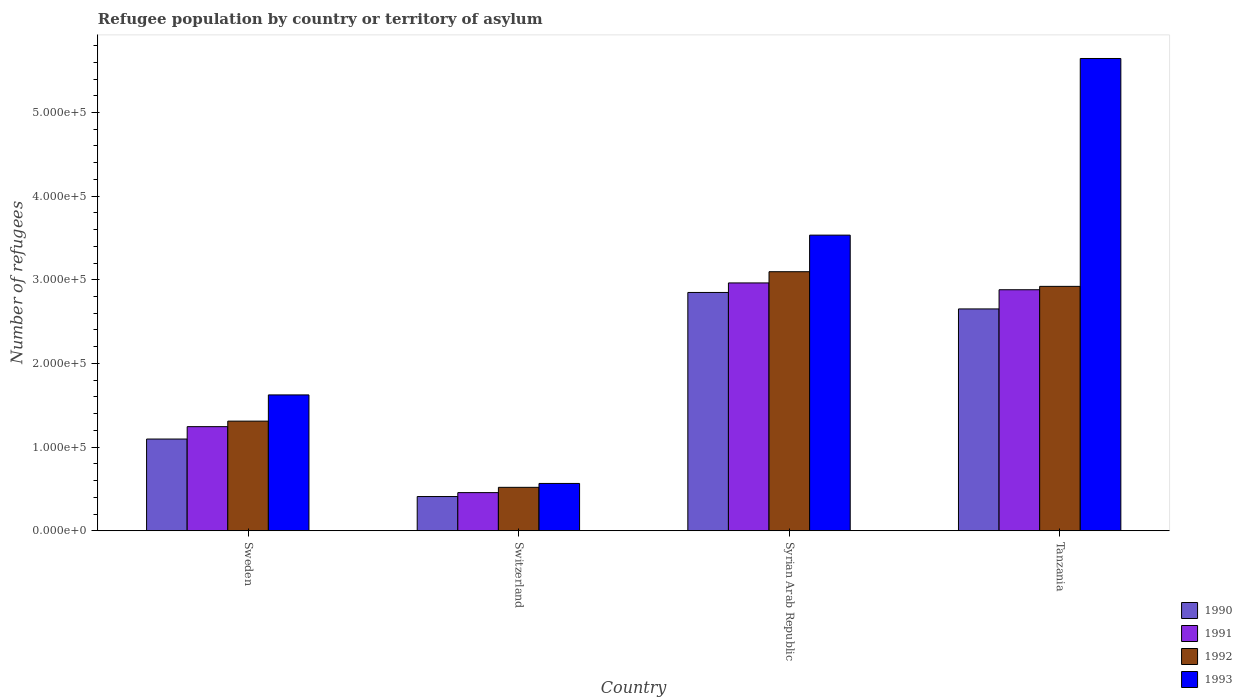Are the number of bars per tick equal to the number of legend labels?
Offer a terse response. Yes. Are the number of bars on each tick of the X-axis equal?
Your answer should be very brief. Yes. How many bars are there on the 2nd tick from the left?
Your answer should be compact. 4. What is the label of the 4th group of bars from the left?
Keep it short and to the point. Tanzania. In how many cases, is the number of bars for a given country not equal to the number of legend labels?
Your answer should be very brief. 0. What is the number of refugees in 1993 in Syrian Arab Republic?
Keep it short and to the point. 3.53e+05. Across all countries, what is the maximum number of refugees in 1991?
Give a very brief answer. 2.96e+05. Across all countries, what is the minimum number of refugees in 1991?
Your response must be concise. 4.56e+04. In which country was the number of refugees in 1993 maximum?
Your response must be concise. Tanzania. In which country was the number of refugees in 1991 minimum?
Give a very brief answer. Switzerland. What is the total number of refugees in 1991 in the graph?
Your answer should be very brief. 7.54e+05. What is the difference between the number of refugees in 1992 in Sweden and that in Switzerland?
Your answer should be very brief. 7.91e+04. What is the difference between the number of refugees in 1993 in Sweden and the number of refugees in 1991 in Syrian Arab Republic?
Your response must be concise. -1.34e+05. What is the average number of refugees in 1991 per country?
Provide a short and direct response. 1.89e+05. What is the difference between the number of refugees of/in 1991 and number of refugees of/in 1993 in Syrian Arab Republic?
Offer a very short reply. -5.71e+04. In how many countries, is the number of refugees in 1991 greater than 400000?
Provide a succinct answer. 0. What is the ratio of the number of refugees in 1992 in Sweden to that in Syrian Arab Republic?
Your response must be concise. 0.42. Is the number of refugees in 1990 in Sweden less than that in Syrian Arab Republic?
Offer a terse response. Yes. Is the difference between the number of refugees in 1991 in Syrian Arab Republic and Tanzania greater than the difference between the number of refugees in 1993 in Syrian Arab Republic and Tanzania?
Offer a very short reply. Yes. What is the difference between the highest and the second highest number of refugees in 1991?
Ensure brevity in your answer.  1.72e+05. What is the difference between the highest and the lowest number of refugees in 1993?
Give a very brief answer. 5.08e+05. Is the sum of the number of refugees in 1992 in Sweden and Switzerland greater than the maximum number of refugees in 1993 across all countries?
Provide a short and direct response. No. What does the 2nd bar from the left in Syrian Arab Republic represents?
Make the answer very short. 1991. What does the 3rd bar from the right in Sweden represents?
Keep it short and to the point. 1991. Is it the case that in every country, the sum of the number of refugees in 1992 and number of refugees in 1993 is greater than the number of refugees in 1990?
Keep it short and to the point. Yes. How many countries are there in the graph?
Provide a short and direct response. 4. Are the values on the major ticks of Y-axis written in scientific E-notation?
Offer a terse response. Yes. Does the graph contain grids?
Keep it short and to the point. No. What is the title of the graph?
Make the answer very short. Refugee population by country or territory of asylum. What is the label or title of the Y-axis?
Give a very brief answer. Number of refugees. What is the Number of refugees of 1990 in Sweden?
Your response must be concise. 1.10e+05. What is the Number of refugees in 1991 in Sweden?
Ensure brevity in your answer.  1.24e+05. What is the Number of refugees in 1992 in Sweden?
Offer a very short reply. 1.31e+05. What is the Number of refugees in 1993 in Sweden?
Ensure brevity in your answer.  1.62e+05. What is the Number of refugees in 1990 in Switzerland?
Make the answer very short. 4.09e+04. What is the Number of refugees in 1991 in Switzerland?
Your answer should be very brief. 4.56e+04. What is the Number of refugees of 1992 in Switzerland?
Offer a very short reply. 5.19e+04. What is the Number of refugees in 1993 in Switzerland?
Your answer should be very brief. 5.66e+04. What is the Number of refugees of 1990 in Syrian Arab Republic?
Offer a terse response. 2.85e+05. What is the Number of refugees of 1991 in Syrian Arab Republic?
Offer a terse response. 2.96e+05. What is the Number of refugees in 1992 in Syrian Arab Republic?
Your answer should be compact. 3.10e+05. What is the Number of refugees in 1993 in Syrian Arab Republic?
Offer a very short reply. 3.53e+05. What is the Number of refugees of 1990 in Tanzania?
Your response must be concise. 2.65e+05. What is the Number of refugees in 1991 in Tanzania?
Your answer should be compact. 2.88e+05. What is the Number of refugees in 1992 in Tanzania?
Your answer should be very brief. 2.92e+05. What is the Number of refugees of 1993 in Tanzania?
Your response must be concise. 5.65e+05. Across all countries, what is the maximum Number of refugees of 1990?
Provide a succinct answer. 2.85e+05. Across all countries, what is the maximum Number of refugees in 1991?
Provide a short and direct response. 2.96e+05. Across all countries, what is the maximum Number of refugees of 1992?
Provide a succinct answer. 3.10e+05. Across all countries, what is the maximum Number of refugees in 1993?
Your response must be concise. 5.65e+05. Across all countries, what is the minimum Number of refugees in 1990?
Offer a terse response. 4.09e+04. Across all countries, what is the minimum Number of refugees in 1991?
Make the answer very short. 4.56e+04. Across all countries, what is the minimum Number of refugees of 1992?
Provide a succinct answer. 5.19e+04. Across all countries, what is the minimum Number of refugees in 1993?
Offer a terse response. 5.66e+04. What is the total Number of refugees in 1990 in the graph?
Your answer should be compact. 7.01e+05. What is the total Number of refugees of 1991 in the graph?
Ensure brevity in your answer.  7.54e+05. What is the total Number of refugees of 1992 in the graph?
Your response must be concise. 7.85e+05. What is the total Number of refugees of 1993 in the graph?
Make the answer very short. 1.14e+06. What is the difference between the Number of refugees in 1990 in Sweden and that in Switzerland?
Provide a short and direct response. 6.87e+04. What is the difference between the Number of refugees in 1991 in Sweden and that in Switzerland?
Provide a succinct answer. 7.88e+04. What is the difference between the Number of refugees in 1992 in Sweden and that in Switzerland?
Give a very brief answer. 7.91e+04. What is the difference between the Number of refugees of 1993 in Sweden and that in Switzerland?
Offer a very short reply. 1.06e+05. What is the difference between the Number of refugees of 1990 in Sweden and that in Syrian Arab Republic?
Offer a very short reply. -1.75e+05. What is the difference between the Number of refugees of 1991 in Sweden and that in Syrian Arab Republic?
Offer a terse response. -1.72e+05. What is the difference between the Number of refugees in 1992 in Sweden and that in Syrian Arab Republic?
Offer a terse response. -1.79e+05. What is the difference between the Number of refugees in 1993 in Sweden and that in Syrian Arab Republic?
Your answer should be very brief. -1.91e+05. What is the difference between the Number of refugees of 1990 in Sweden and that in Tanzania?
Your answer should be very brief. -1.56e+05. What is the difference between the Number of refugees of 1991 in Sweden and that in Tanzania?
Give a very brief answer. -1.64e+05. What is the difference between the Number of refugees of 1992 in Sweden and that in Tanzania?
Keep it short and to the point. -1.61e+05. What is the difference between the Number of refugees in 1993 in Sweden and that in Tanzania?
Your response must be concise. -4.02e+05. What is the difference between the Number of refugees of 1990 in Switzerland and that in Syrian Arab Republic?
Give a very brief answer. -2.44e+05. What is the difference between the Number of refugees in 1991 in Switzerland and that in Syrian Arab Republic?
Your answer should be compact. -2.51e+05. What is the difference between the Number of refugees in 1992 in Switzerland and that in Syrian Arab Republic?
Ensure brevity in your answer.  -2.58e+05. What is the difference between the Number of refugees of 1993 in Switzerland and that in Syrian Arab Republic?
Provide a succinct answer. -2.97e+05. What is the difference between the Number of refugees of 1990 in Switzerland and that in Tanzania?
Your answer should be compact. -2.24e+05. What is the difference between the Number of refugees of 1991 in Switzerland and that in Tanzania?
Provide a short and direct response. -2.42e+05. What is the difference between the Number of refugees of 1992 in Switzerland and that in Tanzania?
Offer a very short reply. -2.40e+05. What is the difference between the Number of refugees of 1993 in Switzerland and that in Tanzania?
Offer a very short reply. -5.08e+05. What is the difference between the Number of refugees in 1990 in Syrian Arab Republic and that in Tanzania?
Your answer should be very brief. 1.97e+04. What is the difference between the Number of refugees of 1991 in Syrian Arab Republic and that in Tanzania?
Your answer should be very brief. 8153. What is the difference between the Number of refugees of 1992 in Syrian Arab Republic and that in Tanzania?
Keep it short and to the point. 1.75e+04. What is the difference between the Number of refugees in 1993 in Syrian Arab Republic and that in Tanzania?
Provide a short and direct response. -2.11e+05. What is the difference between the Number of refugees in 1990 in Sweden and the Number of refugees in 1991 in Switzerland?
Keep it short and to the point. 6.40e+04. What is the difference between the Number of refugees in 1990 in Sweden and the Number of refugees in 1992 in Switzerland?
Give a very brief answer. 5.77e+04. What is the difference between the Number of refugees of 1990 in Sweden and the Number of refugees of 1993 in Switzerland?
Your answer should be compact. 5.31e+04. What is the difference between the Number of refugees of 1991 in Sweden and the Number of refugees of 1992 in Switzerland?
Provide a short and direct response. 7.25e+04. What is the difference between the Number of refugees of 1991 in Sweden and the Number of refugees of 1993 in Switzerland?
Ensure brevity in your answer.  6.79e+04. What is the difference between the Number of refugees of 1992 in Sweden and the Number of refugees of 1993 in Switzerland?
Make the answer very short. 7.45e+04. What is the difference between the Number of refugees in 1990 in Sweden and the Number of refugees in 1991 in Syrian Arab Republic?
Your answer should be compact. -1.87e+05. What is the difference between the Number of refugees of 1990 in Sweden and the Number of refugees of 1992 in Syrian Arab Republic?
Offer a very short reply. -2.00e+05. What is the difference between the Number of refugees in 1990 in Sweden and the Number of refugees in 1993 in Syrian Arab Republic?
Keep it short and to the point. -2.44e+05. What is the difference between the Number of refugees in 1991 in Sweden and the Number of refugees in 1992 in Syrian Arab Republic?
Offer a terse response. -1.85e+05. What is the difference between the Number of refugees of 1991 in Sweden and the Number of refugees of 1993 in Syrian Arab Republic?
Your answer should be very brief. -2.29e+05. What is the difference between the Number of refugees in 1992 in Sweden and the Number of refugees in 1993 in Syrian Arab Republic?
Provide a short and direct response. -2.22e+05. What is the difference between the Number of refugees in 1990 in Sweden and the Number of refugees in 1991 in Tanzania?
Provide a short and direct response. -1.78e+05. What is the difference between the Number of refugees in 1990 in Sweden and the Number of refugees in 1992 in Tanzania?
Your answer should be very brief. -1.82e+05. What is the difference between the Number of refugees of 1990 in Sweden and the Number of refugees of 1993 in Tanzania?
Make the answer very short. -4.55e+05. What is the difference between the Number of refugees in 1991 in Sweden and the Number of refugees in 1992 in Tanzania?
Your answer should be very brief. -1.68e+05. What is the difference between the Number of refugees of 1991 in Sweden and the Number of refugees of 1993 in Tanzania?
Your answer should be compact. -4.40e+05. What is the difference between the Number of refugees in 1992 in Sweden and the Number of refugees in 1993 in Tanzania?
Your answer should be very brief. -4.33e+05. What is the difference between the Number of refugees in 1990 in Switzerland and the Number of refugees in 1991 in Syrian Arab Republic?
Your response must be concise. -2.55e+05. What is the difference between the Number of refugees of 1990 in Switzerland and the Number of refugees of 1992 in Syrian Arab Republic?
Make the answer very short. -2.69e+05. What is the difference between the Number of refugees of 1990 in Switzerland and the Number of refugees of 1993 in Syrian Arab Republic?
Your answer should be very brief. -3.12e+05. What is the difference between the Number of refugees in 1991 in Switzerland and the Number of refugees in 1992 in Syrian Arab Republic?
Your response must be concise. -2.64e+05. What is the difference between the Number of refugees of 1991 in Switzerland and the Number of refugees of 1993 in Syrian Arab Republic?
Provide a succinct answer. -3.08e+05. What is the difference between the Number of refugees of 1992 in Switzerland and the Number of refugees of 1993 in Syrian Arab Republic?
Provide a short and direct response. -3.01e+05. What is the difference between the Number of refugees in 1990 in Switzerland and the Number of refugees in 1991 in Tanzania?
Provide a short and direct response. -2.47e+05. What is the difference between the Number of refugees in 1990 in Switzerland and the Number of refugees in 1992 in Tanzania?
Provide a short and direct response. -2.51e+05. What is the difference between the Number of refugees in 1990 in Switzerland and the Number of refugees in 1993 in Tanzania?
Offer a very short reply. -5.24e+05. What is the difference between the Number of refugees in 1991 in Switzerland and the Number of refugees in 1992 in Tanzania?
Keep it short and to the point. -2.47e+05. What is the difference between the Number of refugees of 1991 in Switzerland and the Number of refugees of 1993 in Tanzania?
Make the answer very short. -5.19e+05. What is the difference between the Number of refugees in 1992 in Switzerland and the Number of refugees in 1993 in Tanzania?
Give a very brief answer. -5.13e+05. What is the difference between the Number of refugees of 1990 in Syrian Arab Republic and the Number of refugees of 1991 in Tanzania?
Provide a succinct answer. -3247. What is the difference between the Number of refugees in 1990 in Syrian Arab Republic and the Number of refugees in 1992 in Tanzania?
Offer a very short reply. -7292. What is the difference between the Number of refugees in 1990 in Syrian Arab Republic and the Number of refugees in 1993 in Tanzania?
Your answer should be compact. -2.80e+05. What is the difference between the Number of refugees of 1991 in Syrian Arab Republic and the Number of refugees of 1992 in Tanzania?
Provide a succinct answer. 4108. What is the difference between the Number of refugees in 1991 in Syrian Arab Republic and the Number of refugees in 1993 in Tanzania?
Your response must be concise. -2.68e+05. What is the difference between the Number of refugees in 1992 in Syrian Arab Republic and the Number of refugees in 1993 in Tanzania?
Offer a very short reply. -2.55e+05. What is the average Number of refugees in 1990 per country?
Ensure brevity in your answer.  1.75e+05. What is the average Number of refugees in 1991 per country?
Provide a short and direct response. 1.89e+05. What is the average Number of refugees in 1992 per country?
Your response must be concise. 1.96e+05. What is the average Number of refugees of 1993 per country?
Offer a terse response. 2.84e+05. What is the difference between the Number of refugees of 1990 and Number of refugees of 1991 in Sweden?
Ensure brevity in your answer.  -1.48e+04. What is the difference between the Number of refugees of 1990 and Number of refugees of 1992 in Sweden?
Provide a short and direct response. -2.14e+04. What is the difference between the Number of refugees in 1990 and Number of refugees in 1993 in Sweden?
Your answer should be very brief. -5.27e+04. What is the difference between the Number of refugees of 1991 and Number of refugees of 1992 in Sweden?
Your response must be concise. -6603. What is the difference between the Number of refugees of 1991 and Number of refugees of 1993 in Sweden?
Keep it short and to the point. -3.79e+04. What is the difference between the Number of refugees in 1992 and Number of refugees in 1993 in Sweden?
Your answer should be very brief. -3.13e+04. What is the difference between the Number of refugees in 1990 and Number of refugees in 1991 in Switzerland?
Your answer should be very brief. -4679. What is the difference between the Number of refugees of 1990 and Number of refugees of 1992 in Switzerland?
Your response must be concise. -1.10e+04. What is the difference between the Number of refugees of 1990 and Number of refugees of 1993 in Switzerland?
Your answer should be compact. -1.56e+04. What is the difference between the Number of refugees in 1991 and Number of refugees in 1992 in Switzerland?
Give a very brief answer. -6308. What is the difference between the Number of refugees in 1991 and Number of refugees in 1993 in Switzerland?
Keep it short and to the point. -1.10e+04. What is the difference between the Number of refugees of 1992 and Number of refugees of 1993 in Switzerland?
Offer a very short reply. -4656. What is the difference between the Number of refugees of 1990 and Number of refugees of 1991 in Syrian Arab Republic?
Give a very brief answer. -1.14e+04. What is the difference between the Number of refugees of 1990 and Number of refugees of 1992 in Syrian Arab Republic?
Keep it short and to the point. -2.48e+04. What is the difference between the Number of refugees in 1990 and Number of refugees in 1993 in Syrian Arab Republic?
Your answer should be compact. -6.85e+04. What is the difference between the Number of refugees of 1991 and Number of refugees of 1992 in Syrian Arab Republic?
Ensure brevity in your answer.  -1.34e+04. What is the difference between the Number of refugees of 1991 and Number of refugees of 1993 in Syrian Arab Republic?
Provide a short and direct response. -5.71e+04. What is the difference between the Number of refugees in 1992 and Number of refugees in 1993 in Syrian Arab Republic?
Give a very brief answer. -4.37e+04. What is the difference between the Number of refugees in 1990 and Number of refugees in 1991 in Tanzania?
Provide a succinct answer. -2.29e+04. What is the difference between the Number of refugees in 1990 and Number of refugees in 1992 in Tanzania?
Give a very brief answer. -2.70e+04. What is the difference between the Number of refugees of 1990 and Number of refugees of 1993 in Tanzania?
Ensure brevity in your answer.  -2.99e+05. What is the difference between the Number of refugees in 1991 and Number of refugees in 1992 in Tanzania?
Keep it short and to the point. -4045. What is the difference between the Number of refugees of 1991 and Number of refugees of 1993 in Tanzania?
Ensure brevity in your answer.  -2.76e+05. What is the difference between the Number of refugees in 1992 and Number of refugees in 1993 in Tanzania?
Ensure brevity in your answer.  -2.72e+05. What is the ratio of the Number of refugees of 1990 in Sweden to that in Switzerland?
Give a very brief answer. 2.68. What is the ratio of the Number of refugees of 1991 in Sweden to that in Switzerland?
Your answer should be compact. 2.73. What is the ratio of the Number of refugees in 1992 in Sweden to that in Switzerland?
Your answer should be very brief. 2.52. What is the ratio of the Number of refugees of 1993 in Sweden to that in Switzerland?
Offer a very short reply. 2.87. What is the ratio of the Number of refugees of 1990 in Sweden to that in Syrian Arab Republic?
Keep it short and to the point. 0.39. What is the ratio of the Number of refugees in 1991 in Sweden to that in Syrian Arab Republic?
Your answer should be very brief. 0.42. What is the ratio of the Number of refugees of 1992 in Sweden to that in Syrian Arab Republic?
Provide a succinct answer. 0.42. What is the ratio of the Number of refugees of 1993 in Sweden to that in Syrian Arab Republic?
Keep it short and to the point. 0.46. What is the ratio of the Number of refugees in 1990 in Sweden to that in Tanzania?
Offer a terse response. 0.41. What is the ratio of the Number of refugees of 1991 in Sweden to that in Tanzania?
Provide a short and direct response. 0.43. What is the ratio of the Number of refugees in 1992 in Sweden to that in Tanzania?
Keep it short and to the point. 0.45. What is the ratio of the Number of refugees in 1993 in Sweden to that in Tanzania?
Offer a very short reply. 0.29. What is the ratio of the Number of refugees of 1990 in Switzerland to that in Syrian Arab Republic?
Your response must be concise. 0.14. What is the ratio of the Number of refugees of 1991 in Switzerland to that in Syrian Arab Republic?
Provide a succinct answer. 0.15. What is the ratio of the Number of refugees in 1992 in Switzerland to that in Syrian Arab Republic?
Offer a very short reply. 0.17. What is the ratio of the Number of refugees of 1993 in Switzerland to that in Syrian Arab Republic?
Ensure brevity in your answer.  0.16. What is the ratio of the Number of refugees of 1990 in Switzerland to that in Tanzania?
Give a very brief answer. 0.15. What is the ratio of the Number of refugees in 1991 in Switzerland to that in Tanzania?
Provide a succinct answer. 0.16. What is the ratio of the Number of refugees of 1992 in Switzerland to that in Tanzania?
Offer a very short reply. 0.18. What is the ratio of the Number of refugees in 1993 in Switzerland to that in Tanzania?
Your response must be concise. 0.1. What is the ratio of the Number of refugees in 1990 in Syrian Arab Republic to that in Tanzania?
Offer a very short reply. 1.07. What is the ratio of the Number of refugees in 1991 in Syrian Arab Republic to that in Tanzania?
Give a very brief answer. 1.03. What is the ratio of the Number of refugees in 1992 in Syrian Arab Republic to that in Tanzania?
Keep it short and to the point. 1.06. What is the ratio of the Number of refugees of 1993 in Syrian Arab Republic to that in Tanzania?
Your answer should be compact. 0.63. What is the difference between the highest and the second highest Number of refugees of 1990?
Your answer should be compact. 1.97e+04. What is the difference between the highest and the second highest Number of refugees in 1991?
Keep it short and to the point. 8153. What is the difference between the highest and the second highest Number of refugees in 1992?
Make the answer very short. 1.75e+04. What is the difference between the highest and the second highest Number of refugees in 1993?
Provide a succinct answer. 2.11e+05. What is the difference between the highest and the lowest Number of refugees of 1990?
Ensure brevity in your answer.  2.44e+05. What is the difference between the highest and the lowest Number of refugees of 1991?
Offer a very short reply. 2.51e+05. What is the difference between the highest and the lowest Number of refugees of 1992?
Keep it short and to the point. 2.58e+05. What is the difference between the highest and the lowest Number of refugees in 1993?
Offer a terse response. 5.08e+05. 